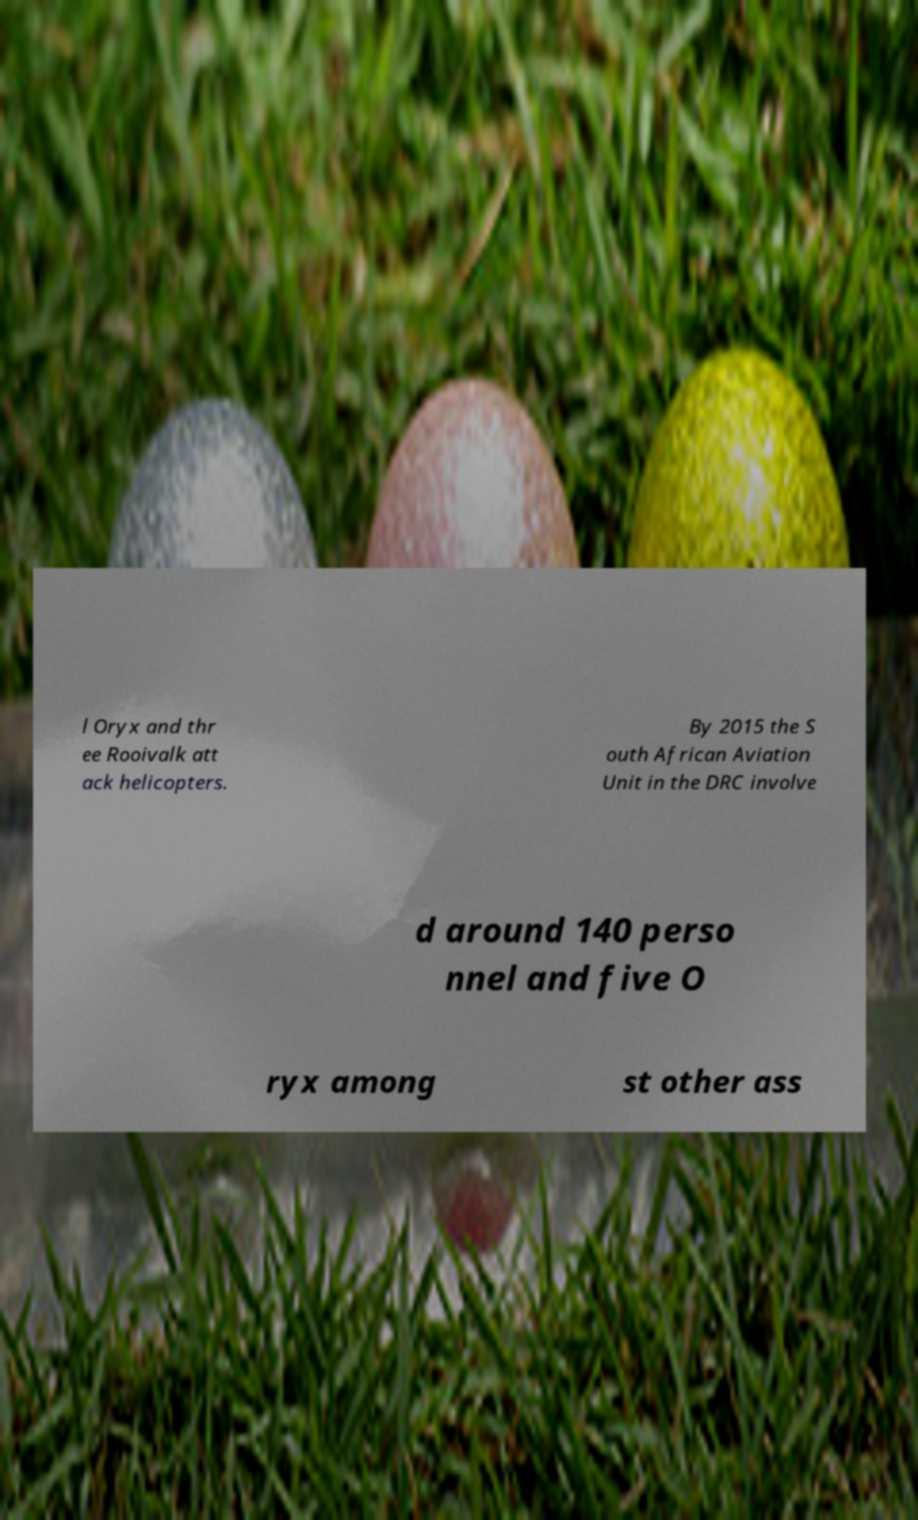I need the written content from this picture converted into text. Can you do that? l Oryx and thr ee Rooivalk att ack helicopters. By 2015 the S outh African Aviation Unit in the DRC involve d around 140 perso nnel and five O ryx among st other ass 